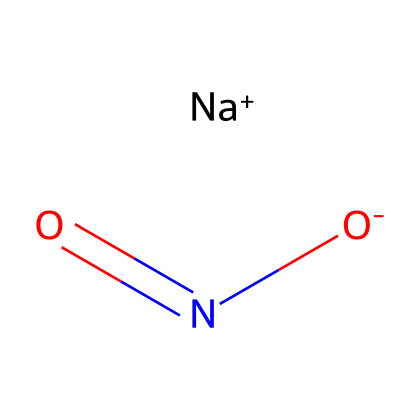What is the total number of atoms in sodium nitrite? The chemical structure shows three distinct elements: sodium (Na), nitrogen (N), and oxygen (O). Counting each atom gives us one Na, one N, and two O, which sums up to a total of four atoms.
Answer: four How many oxygen atoms are present in sodium nitrite? By analyzing the SMILES representation, we see that there are two oxygen (O) atoms depicted in the structure (indicated by the double bond and the single bond to nitrogen).
Answer: two What is the oxidation state of nitrogen in sodium nitrite? In sodium nitrite, nitrogen is bonded to one oxygen atom with a double bond and another oxygen atom with a single bond. This configuration suggests that nitrogen has an oxidation state of +3, considering the formal charges of the surrounding atoms.
Answer: +3 What type of chemical bond connects nitrogen and oxygen in sodium nitrite? The structure shows a nitrogen atom connected to one oxygen atom via a double bond and to another oxygen atom via a single bond. Double bonds are characterized by two shared pairs of electrons, while single bonds have one. Thus, there’s one double bond and one single bond between nitrogen and oxygen in sodium nitrite.
Answer: double and single What is the charge of the sodium ion in sodium nitrite? The structure indicates the presence of Na+, which denotes a sodium ion with a +1 charge. This is a characteristic of sodium when it loses one electron.
Answer: +1 What is the common use of sodium nitrite in food products? Sodium nitrite is primarily used as a food preservative, particularly in cured meats, to prevent bacterial growth and to maintain color. This function is widely documented in food science literature.
Answer: preservative What structural feature indicates that sodium nitrite is an inorganic compound? The presence of the sodium (Na) ion, which is a metal, along with its ionic character, is indicative of an inorganic compound. Such compounds typically do not include carbon-hydrogen bonds which are characteristic of organic compounds.
Answer: sodium ion 